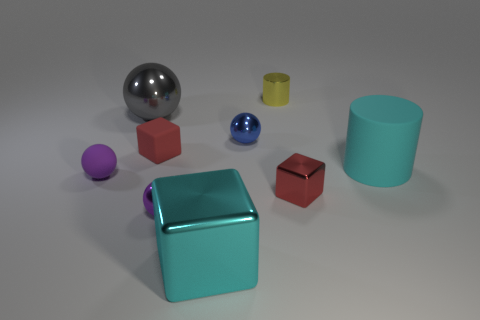Add 1 small cyan cylinders. How many objects exist? 10 Subtract all cylinders. How many objects are left? 7 Subtract all tiny purple objects. Subtract all gray metallic objects. How many objects are left? 6 Add 5 tiny purple metallic balls. How many tiny purple metallic balls are left? 6 Add 9 tiny shiny cubes. How many tiny shiny cubes exist? 10 Subtract 0 brown cubes. How many objects are left? 9 